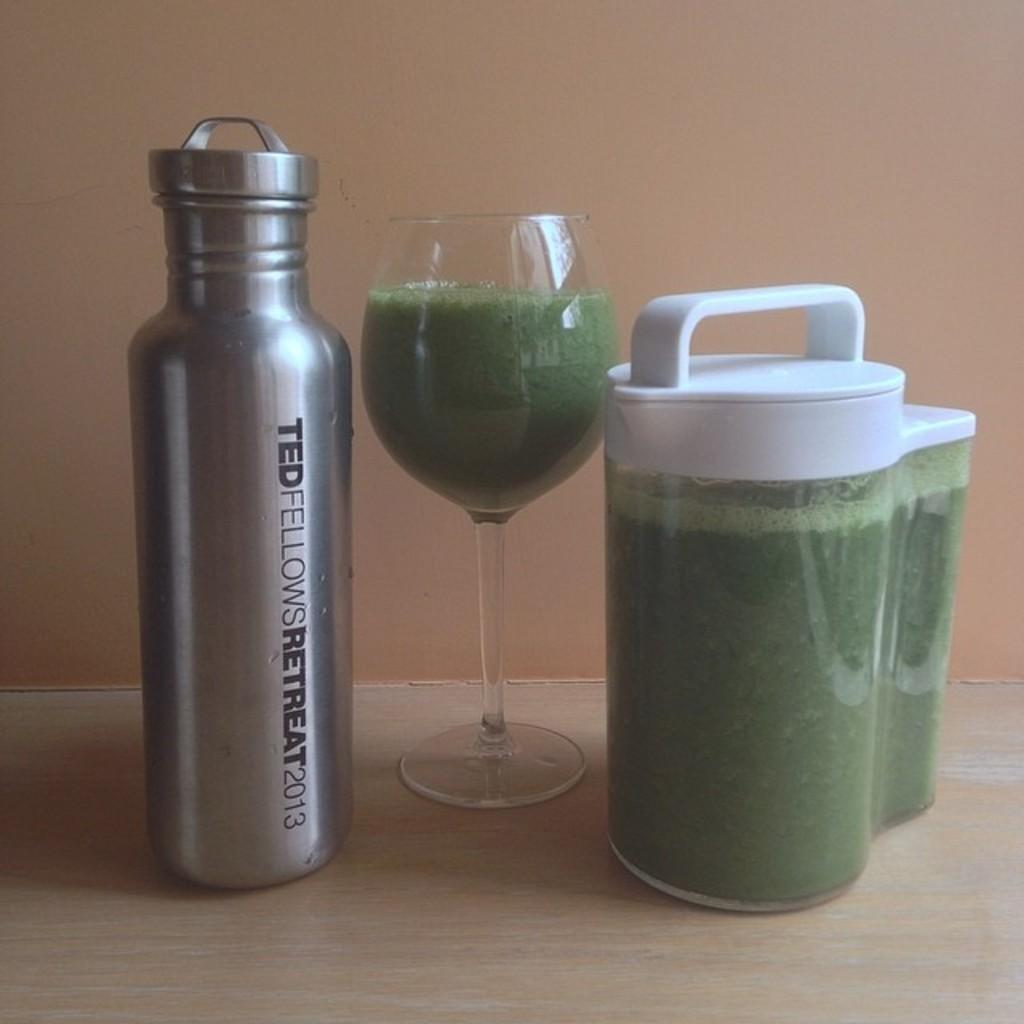<image>
Present a compact description of the photo's key features. Ted Fellows sponsored glass has a green liquid in it 